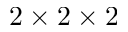<formula> <loc_0><loc_0><loc_500><loc_500>2 \times 2 \times 2</formula> 